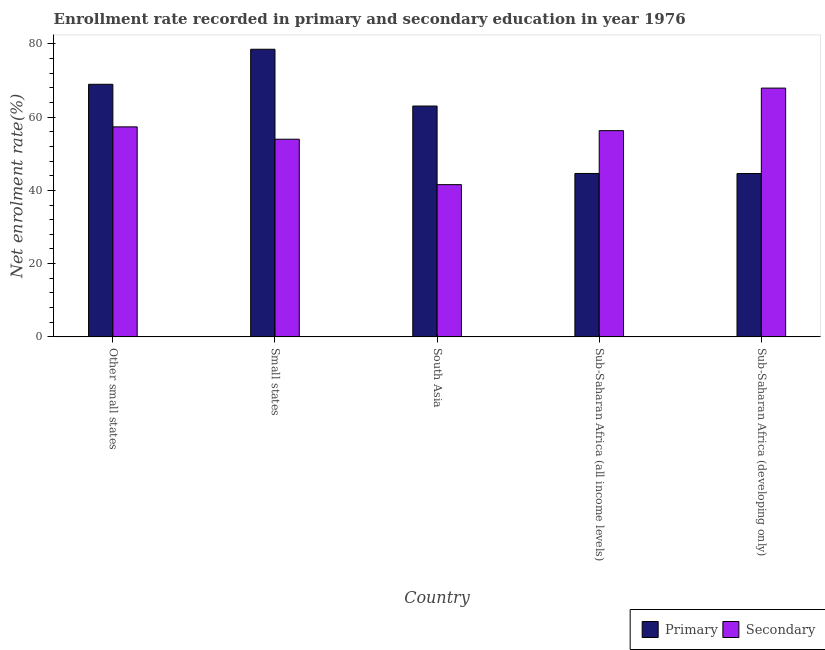How many bars are there on the 3rd tick from the right?
Your response must be concise. 2. What is the label of the 4th group of bars from the left?
Your response must be concise. Sub-Saharan Africa (all income levels). In how many cases, is the number of bars for a given country not equal to the number of legend labels?
Your answer should be very brief. 0. What is the enrollment rate in secondary education in Small states?
Provide a succinct answer. 53.97. Across all countries, what is the maximum enrollment rate in primary education?
Make the answer very short. 78.54. Across all countries, what is the minimum enrollment rate in primary education?
Keep it short and to the point. 44.61. In which country was the enrollment rate in primary education maximum?
Ensure brevity in your answer.  Small states. In which country was the enrollment rate in primary education minimum?
Give a very brief answer. Sub-Saharan Africa (developing only). What is the total enrollment rate in primary education in the graph?
Your answer should be very brief. 299.78. What is the difference between the enrollment rate in secondary education in Other small states and that in Sub-Saharan Africa (developing only)?
Keep it short and to the point. -10.58. What is the difference between the enrollment rate in secondary education in Small states and the enrollment rate in primary education in Sub-Saharan Africa (developing only)?
Provide a succinct answer. 9.37. What is the average enrollment rate in primary education per country?
Make the answer very short. 59.96. What is the difference between the enrollment rate in secondary education and enrollment rate in primary education in Small states?
Your answer should be very brief. -24.57. In how many countries, is the enrollment rate in primary education greater than 16 %?
Offer a very short reply. 5. What is the ratio of the enrollment rate in secondary education in Sub-Saharan Africa (all income levels) to that in Sub-Saharan Africa (developing only)?
Offer a terse response. 0.83. What is the difference between the highest and the second highest enrollment rate in primary education?
Offer a terse response. 9.57. What is the difference between the highest and the lowest enrollment rate in primary education?
Your response must be concise. 33.94. In how many countries, is the enrollment rate in secondary education greater than the average enrollment rate in secondary education taken over all countries?
Your answer should be compact. 3. What does the 1st bar from the left in Small states represents?
Offer a very short reply. Primary. What does the 1st bar from the right in Sub-Saharan Africa (developing only) represents?
Give a very brief answer. Secondary. Are all the bars in the graph horizontal?
Ensure brevity in your answer.  No. Does the graph contain any zero values?
Make the answer very short. No. What is the title of the graph?
Your response must be concise. Enrollment rate recorded in primary and secondary education in year 1976. Does "Working only" appear as one of the legend labels in the graph?
Your answer should be very brief. No. What is the label or title of the X-axis?
Offer a terse response. Country. What is the label or title of the Y-axis?
Provide a short and direct response. Net enrolment rate(%). What is the Net enrolment rate(%) of Primary in Other small states?
Provide a short and direct response. 68.97. What is the Net enrolment rate(%) of Secondary in Other small states?
Give a very brief answer. 57.35. What is the Net enrolment rate(%) in Primary in Small states?
Your answer should be very brief. 78.54. What is the Net enrolment rate(%) of Secondary in Small states?
Give a very brief answer. 53.97. What is the Net enrolment rate(%) in Primary in South Asia?
Offer a very short reply. 63.04. What is the Net enrolment rate(%) of Secondary in South Asia?
Your response must be concise. 41.57. What is the Net enrolment rate(%) of Primary in Sub-Saharan Africa (all income levels)?
Provide a short and direct response. 44.62. What is the Net enrolment rate(%) of Secondary in Sub-Saharan Africa (all income levels)?
Provide a succinct answer. 56.32. What is the Net enrolment rate(%) in Primary in Sub-Saharan Africa (developing only)?
Your answer should be compact. 44.61. What is the Net enrolment rate(%) of Secondary in Sub-Saharan Africa (developing only)?
Your answer should be very brief. 67.93. Across all countries, what is the maximum Net enrolment rate(%) in Primary?
Your answer should be compact. 78.54. Across all countries, what is the maximum Net enrolment rate(%) of Secondary?
Provide a succinct answer. 67.93. Across all countries, what is the minimum Net enrolment rate(%) of Primary?
Offer a very short reply. 44.61. Across all countries, what is the minimum Net enrolment rate(%) of Secondary?
Your answer should be very brief. 41.57. What is the total Net enrolment rate(%) of Primary in the graph?
Provide a succinct answer. 299.78. What is the total Net enrolment rate(%) in Secondary in the graph?
Your response must be concise. 277.14. What is the difference between the Net enrolment rate(%) in Primary in Other small states and that in Small states?
Give a very brief answer. -9.57. What is the difference between the Net enrolment rate(%) of Secondary in Other small states and that in Small states?
Give a very brief answer. 3.38. What is the difference between the Net enrolment rate(%) of Primary in Other small states and that in South Asia?
Provide a short and direct response. 5.94. What is the difference between the Net enrolment rate(%) of Secondary in Other small states and that in South Asia?
Give a very brief answer. 15.78. What is the difference between the Net enrolment rate(%) in Primary in Other small states and that in Sub-Saharan Africa (all income levels)?
Give a very brief answer. 24.35. What is the difference between the Net enrolment rate(%) in Secondary in Other small states and that in Sub-Saharan Africa (all income levels)?
Your response must be concise. 1.03. What is the difference between the Net enrolment rate(%) of Primary in Other small states and that in Sub-Saharan Africa (developing only)?
Ensure brevity in your answer.  24.37. What is the difference between the Net enrolment rate(%) in Secondary in Other small states and that in Sub-Saharan Africa (developing only)?
Provide a short and direct response. -10.58. What is the difference between the Net enrolment rate(%) in Primary in Small states and that in South Asia?
Your response must be concise. 15.51. What is the difference between the Net enrolment rate(%) in Secondary in Small states and that in South Asia?
Give a very brief answer. 12.4. What is the difference between the Net enrolment rate(%) of Primary in Small states and that in Sub-Saharan Africa (all income levels)?
Make the answer very short. 33.92. What is the difference between the Net enrolment rate(%) in Secondary in Small states and that in Sub-Saharan Africa (all income levels)?
Provide a succinct answer. -2.34. What is the difference between the Net enrolment rate(%) in Primary in Small states and that in Sub-Saharan Africa (developing only)?
Ensure brevity in your answer.  33.94. What is the difference between the Net enrolment rate(%) of Secondary in Small states and that in Sub-Saharan Africa (developing only)?
Your answer should be compact. -13.96. What is the difference between the Net enrolment rate(%) in Primary in South Asia and that in Sub-Saharan Africa (all income levels)?
Keep it short and to the point. 18.41. What is the difference between the Net enrolment rate(%) of Secondary in South Asia and that in Sub-Saharan Africa (all income levels)?
Provide a succinct answer. -14.74. What is the difference between the Net enrolment rate(%) in Primary in South Asia and that in Sub-Saharan Africa (developing only)?
Make the answer very short. 18.43. What is the difference between the Net enrolment rate(%) of Secondary in South Asia and that in Sub-Saharan Africa (developing only)?
Offer a very short reply. -26.36. What is the difference between the Net enrolment rate(%) of Primary in Sub-Saharan Africa (all income levels) and that in Sub-Saharan Africa (developing only)?
Ensure brevity in your answer.  0.02. What is the difference between the Net enrolment rate(%) of Secondary in Sub-Saharan Africa (all income levels) and that in Sub-Saharan Africa (developing only)?
Ensure brevity in your answer.  -11.62. What is the difference between the Net enrolment rate(%) of Primary in Other small states and the Net enrolment rate(%) of Secondary in Small states?
Offer a very short reply. 15. What is the difference between the Net enrolment rate(%) of Primary in Other small states and the Net enrolment rate(%) of Secondary in South Asia?
Ensure brevity in your answer.  27.4. What is the difference between the Net enrolment rate(%) in Primary in Other small states and the Net enrolment rate(%) in Secondary in Sub-Saharan Africa (all income levels)?
Keep it short and to the point. 12.66. What is the difference between the Net enrolment rate(%) of Primary in Other small states and the Net enrolment rate(%) of Secondary in Sub-Saharan Africa (developing only)?
Your answer should be compact. 1.04. What is the difference between the Net enrolment rate(%) in Primary in Small states and the Net enrolment rate(%) in Secondary in South Asia?
Your answer should be very brief. 36.97. What is the difference between the Net enrolment rate(%) of Primary in Small states and the Net enrolment rate(%) of Secondary in Sub-Saharan Africa (all income levels)?
Your answer should be compact. 22.23. What is the difference between the Net enrolment rate(%) of Primary in Small states and the Net enrolment rate(%) of Secondary in Sub-Saharan Africa (developing only)?
Offer a very short reply. 10.61. What is the difference between the Net enrolment rate(%) of Primary in South Asia and the Net enrolment rate(%) of Secondary in Sub-Saharan Africa (all income levels)?
Make the answer very short. 6.72. What is the difference between the Net enrolment rate(%) in Primary in South Asia and the Net enrolment rate(%) in Secondary in Sub-Saharan Africa (developing only)?
Give a very brief answer. -4.9. What is the difference between the Net enrolment rate(%) of Primary in Sub-Saharan Africa (all income levels) and the Net enrolment rate(%) of Secondary in Sub-Saharan Africa (developing only)?
Provide a succinct answer. -23.31. What is the average Net enrolment rate(%) in Primary per country?
Offer a very short reply. 59.96. What is the average Net enrolment rate(%) in Secondary per country?
Your response must be concise. 55.43. What is the difference between the Net enrolment rate(%) in Primary and Net enrolment rate(%) in Secondary in Other small states?
Your response must be concise. 11.63. What is the difference between the Net enrolment rate(%) of Primary and Net enrolment rate(%) of Secondary in Small states?
Provide a short and direct response. 24.57. What is the difference between the Net enrolment rate(%) in Primary and Net enrolment rate(%) in Secondary in South Asia?
Keep it short and to the point. 21.46. What is the difference between the Net enrolment rate(%) in Primary and Net enrolment rate(%) in Secondary in Sub-Saharan Africa (all income levels)?
Offer a very short reply. -11.69. What is the difference between the Net enrolment rate(%) of Primary and Net enrolment rate(%) of Secondary in Sub-Saharan Africa (developing only)?
Your answer should be compact. -23.33. What is the ratio of the Net enrolment rate(%) in Primary in Other small states to that in Small states?
Offer a terse response. 0.88. What is the ratio of the Net enrolment rate(%) of Secondary in Other small states to that in Small states?
Your answer should be compact. 1.06. What is the ratio of the Net enrolment rate(%) of Primary in Other small states to that in South Asia?
Your response must be concise. 1.09. What is the ratio of the Net enrolment rate(%) of Secondary in Other small states to that in South Asia?
Your response must be concise. 1.38. What is the ratio of the Net enrolment rate(%) of Primary in Other small states to that in Sub-Saharan Africa (all income levels)?
Make the answer very short. 1.55. What is the ratio of the Net enrolment rate(%) of Secondary in Other small states to that in Sub-Saharan Africa (all income levels)?
Offer a terse response. 1.02. What is the ratio of the Net enrolment rate(%) of Primary in Other small states to that in Sub-Saharan Africa (developing only)?
Your answer should be very brief. 1.55. What is the ratio of the Net enrolment rate(%) in Secondary in Other small states to that in Sub-Saharan Africa (developing only)?
Offer a very short reply. 0.84. What is the ratio of the Net enrolment rate(%) in Primary in Small states to that in South Asia?
Provide a succinct answer. 1.25. What is the ratio of the Net enrolment rate(%) of Secondary in Small states to that in South Asia?
Give a very brief answer. 1.3. What is the ratio of the Net enrolment rate(%) in Primary in Small states to that in Sub-Saharan Africa (all income levels)?
Provide a short and direct response. 1.76. What is the ratio of the Net enrolment rate(%) in Secondary in Small states to that in Sub-Saharan Africa (all income levels)?
Offer a very short reply. 0.96. What is the ratio of the Net enrolment rate(%) of Primary in Small states to that in Sub-Saharan Africa (developing only)?
Give a very brief answer. 1.76. What is the ratio of the Net enrolment rate(%) of Secondary in Small states to that in Sub-Saharan Africa (developing only)?
Your answer should be very brief. 0.79. What is the ratio of the Net enrolment rate(%) in Primary in South Asia to that in Sub-Saharan Africa (all income levels)?
Offer a terse response. 1.41. What is the ratio of the Net enrolment rate(%) of Secondary in South Asia to that in Sub-Saharan Africa (all income levels)?
Ensure brevity in your answer.  0.74. What is the ratio of the Net enrolment rate(%) in Primary in South Asia to that in Sub-Saharan Africa (developing only)?
Give a very brief answer. 1.41. What is the ratio of the Net enrolment rate(%) of Secondary in South Asia to that in Sub-Saharan Africa (developing only)?
Your answer should be compact. 0.61. What is the ratio of the Net enrolment rate(%) in Primary in Sub-Saharan Africa (all income levels) to that in Sub-Saharan Africa (developing only)?
Give a very brief answer. 1. What is the ratio of the Net enrolment rate(%) of Secondary in Sub-Saharan Africa (all income levels) to that in Sub-Saharan Africa (developing only)?
Your answer should be very brief. 0.83. What is the difference between the highest and the second highest Net enrolment rate(%) in Primary?
Provide a succinct answer. 9.57. What is the difference between the highest and the second highest Net enrolment rate(%) in Secondary?
Keep it short and to the point. 10.58. What is the difference between the highest and the lowest Net enrolment rate(%) of Primary?
Offer a terse response. 33.94. What is the difference between the highest and the lowest Net enrolment rate(%) in Secondary?
Your answer should be very brief. 26.36. 